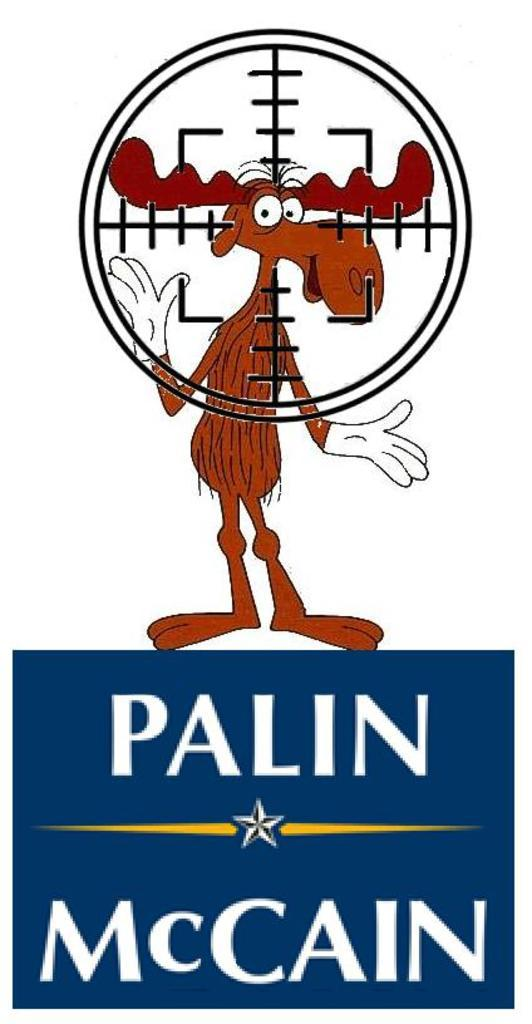Provide a one-sentence caption for the provided image. An image of Bullwinkle in crosshairs standing on a blue "Palin McCain" logo. 